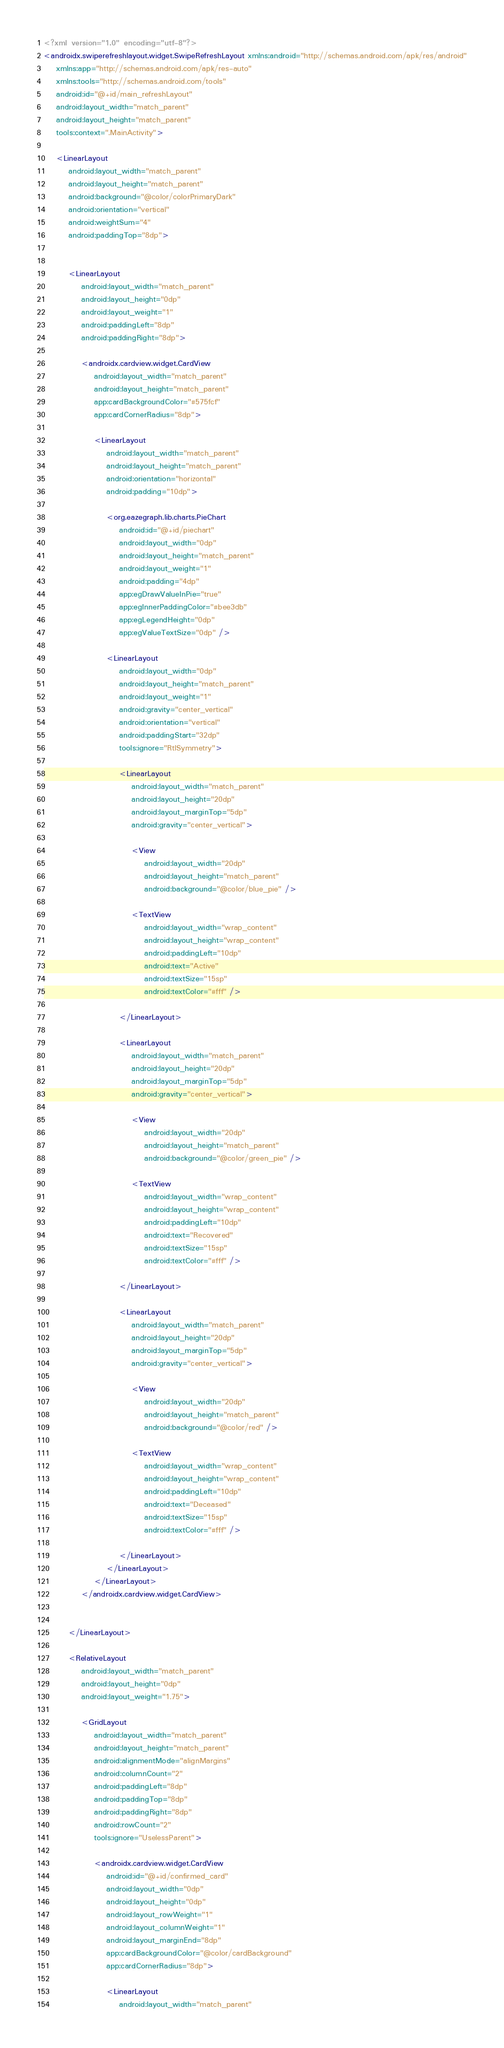<code> <loc_0><loc_0><loc_500><loc_500><_XML_><?xml version="1.0" encoding="utf-8"?>
<androidx.swiperefreshlayout.widget.SwipeRefreshLayout xmlns:android="http://schemas.android.com/apk/res/android"
    xmlns:app="http://schemas.android.com/apk/res-auto"
    xmlns:tools="http://schemas.android.com/tools"
    android:id="@+id/main_refreshLayout"
    android:layout_width="match_parent"
    android:layout_height="match_parent"
    tools:context=".MainActivity">

    <LinearLayout
        android:layout_width="match_parent"
        android:layout_height="match_parent"
        android:background="@color/colorPrimaryDark"
        android:orientation="vertical"
        android:weightSum="4"
        android:paddingTop="8dp">


        <LinearLayout
            android:layout_width="match_parent"
            android:layout_height="0dp"
            android:layout_weight="1"
            android:paddingLeft="8dp"
            android:paddingRight="8dp">

            <androidx.cardview.widget.CardView
                android:layout_width="match_parent"
                android:layout_height="match_parent"
                app:cardBackgroundColor="#575fcf"
                app:cardCornerRadius="8dp">

                <LinearLayout
                    android:layout_width="match_parent"
                    android:layout_height="match_parent"
                    android:orientation="horizontal"
                    android:padding="10dp">

                    <org.eazegraph.lib.charts.PieChart
                        android:id="@+id/piechart"
                        android:layout_width="0dp"
                        android:layout_height="match_parent"
                        android:layout_weight="1"
                        android:padding="4dp"
                        app:egDrawValueInPie="true"
                        app:egInnerPaddingColor="#bee3db"
                        app:egLegendHeight="0dp"
                        app:egValueTextSize="0dp" />

                    <LinearLayout
                        android:layout_width="0dp"
                        android:layout_height="match_parent"
                        android:layout_weight="1"
                        android:gravity="center_vertical"
                        android:orientation="vertical"
                        android:paddingStart="32dp"
                        tools:ignore="RtlSymmetry">

                        <LinearLayout
                            android:layout_width="match_parent"
                            android:layout_height="20dp"
                            android:layout_marginTop="5dp"
                            android:gravity="center_vertical">

                            <View
                                android:layout_width="20dp"
                                android:layout_height="match_parent"
                                android:background="@color/blue_pie" />

                            <TextView
                                android:layout_width="wrap_content"
                                android:layout_height="wrap_content"
                                android:paddingLeft="10dp"
                                android:text="Active"
                                android:textSize="15sp"
                                android:textColor="#fff" />

                        </LinearLayout>

                        <LinearLayout
                            android:layout_width="match_parent"
                            android:layout_height="20dp"
                            android:layout_marginTop="5dp"
                            android:gravity="center_vertical">

                            <View
                                android:layout_width="20dp"
                                android:layout_height="match_parent"
                                android:background="@color/green_pie" />

                            <TextView
                                android:layout_width="wrap_content"
                                android:layout_height="wrap_content"
                                android:paddingLeft="10dp"
                                android:text="Recovered"
                                android:textSize="15sp"
                                android:textColor="#fff" />

                        </LinearLayout>

                        <LinearLayout
                            android:layout_width="match_parent"
                            android:layout_height="20dp"
                            android:layout_marginTop="5dp"
                            android:gravity="center_vertical">

                            <View
                                android:layout_width="20dp"
                                android:layout_height="match_parent"
                                android:background="@color/red" />

                            <TextView
                                android:layout_width="wrap_content"
                                android:layout_height="wrap_content"
                                android:paddingLeft="10dp"
                                android:text="Deceased"
                                android:textSize="15sp"
                                android:textColor="#fff" />

                        </LinearLayout>
                    </LinearLayout>
                </LinearLayout>
            </androidx.cardview.widget.CardView>


        </LinearLayout>

        <RelativeLayout
            android:layout_width="match_parent"
            android:layout_height="0dp"
            android:layout_weight="1.75">

            <GridLayout
                android:layout_width="match_parent"
                android:layout_height="match_parent"
                android:alignmentMode="alignMargins"
                android:columnCount="2"
                android:paddingLeft="8dp"
                android:paddingTop="8dp"
                android:paddingRight="8dp"
                android:rowCount="2"
                tools:ignore="UselessParent">

                <androidx.cardview.widget.CardView
                    android:id="@+id/confirmed_card"
                    android:layout_width="0dp"
                    android:layout_height="0dp"
                    android:layout_rowWeight="1"
                    android:layout_columnWeight="1"
                    android:layout_marginEnd="8dp"
                    app:cardBackgroundColor="@color/cardBackground"
                    app:cardCornerRadius="8dp">

                    <LinearLayout
                        android:layout_width="match_parent"</code> 